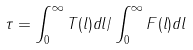Convert formula to latex. <formula><loc_0><loc_0><loc_500><loc_500>\tau = \int _ { 0 } ^ { \infty } T ( l ) d l / \int _ { 0 } ^ { \infty } F ( l ) d l</formula> 